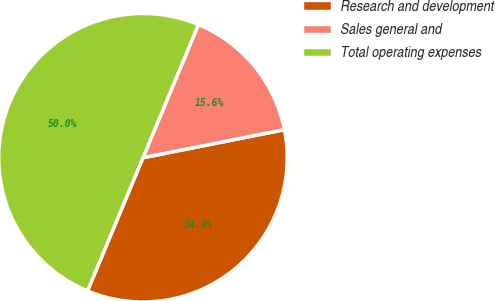Convert chart. <chart><loc_0><loc_0><loc_500><loc_500><pie_chart><fcel>Research and development<fcel>Sales general and<fcel>Total operating expenses<nl><fcel>34.4%<fcel>15.6%<fcel>50.0%<nl></chart> 